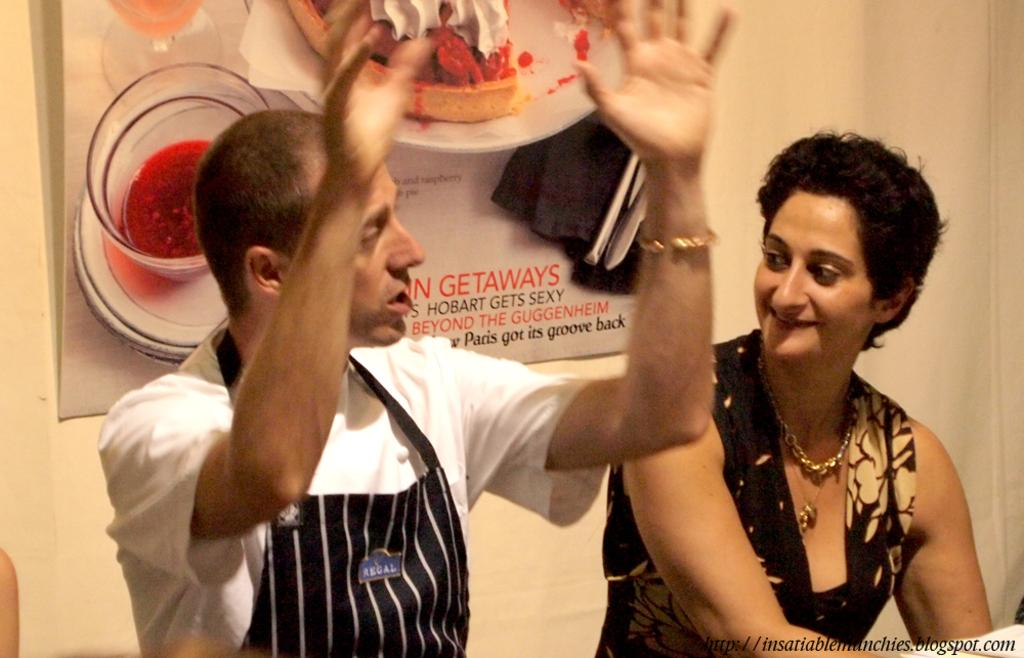Who can be seen in the image? There is a man and a woman in the image. What are they doing in the image? They are sitting at a table. What can be seen in the background of the image? There is a poster and a wall in the background of the image. What type of underwear is the man wearing in the image? There is no information about the man's underwear in the image, as it is not visible or mentioned in the provided facts. 